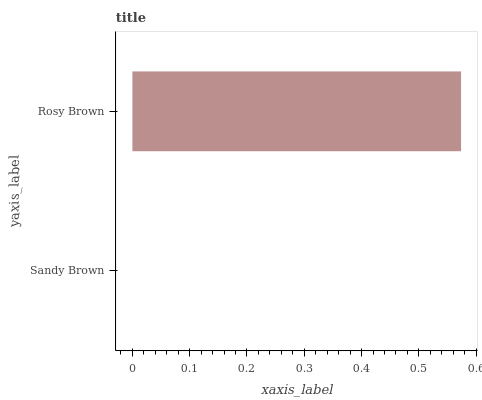Is Sandy Brown the minimum?
Answer yes or no. Yes. Is Rosy Brown the maximum?
Answer yes or no. Yes. Is Rosy Brown the minimum?
Answer yes or no. No. Is Rosy Brown greater than Sandy Brown?
Answer yes or no. Yes. Is Sandy Brown less than Rosy Brown?
Answer yes or no. Yes. Is Sandy Brown greater than Rosy Brown?
Answer yes or no. No. Is Rosy Brown less than Sandy Brown?
Answer yes or no. No. Is Rosy Brown the high median?
Answer yes or no. Yes. Is Sandy Brown the low median?
Answer yes or no. Yes. Is Sandy Brown the high median?
Answer yes or no. No. Is Rosy Brown the low median?
Answer yes or no. No. 